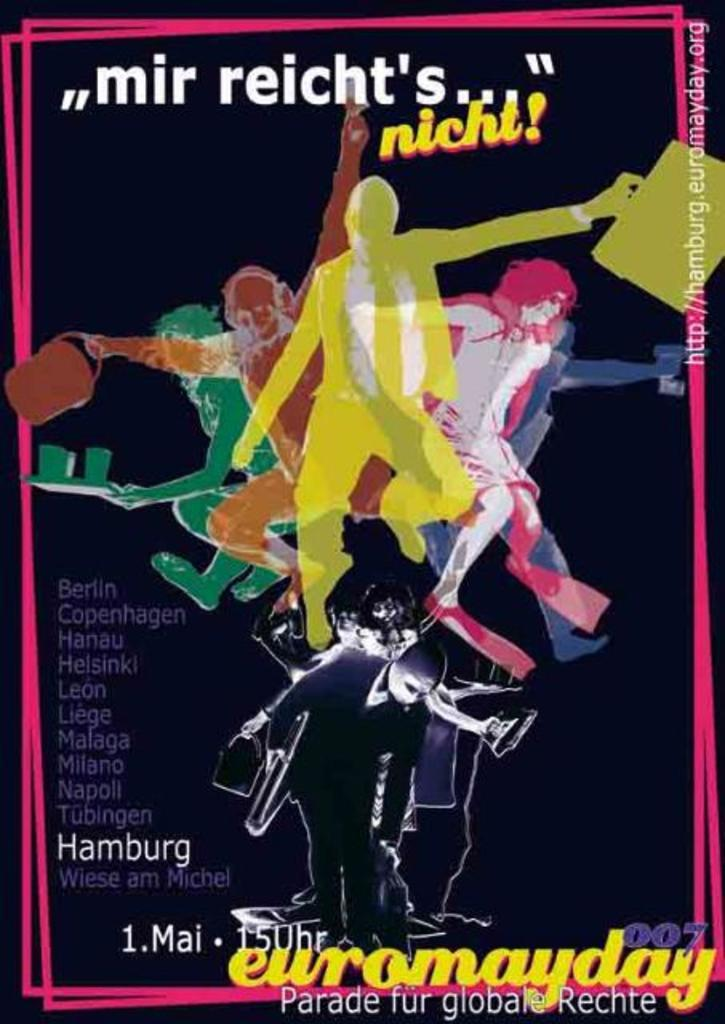<image>
Relay a brief, clear account of the picture shown. Poster for "Euromayday" showing a collage of people holding things. 